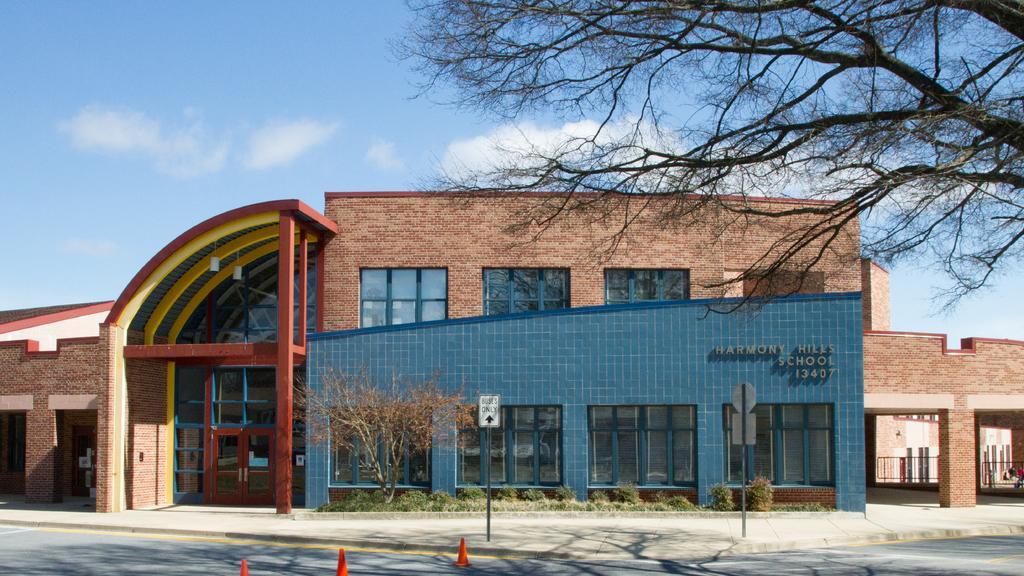Please provide a concise description of this image. In this picture we can see a building, in front of the building we can see trees, sign boards, metal rods and road divider cones, in the background we can see clouds. 